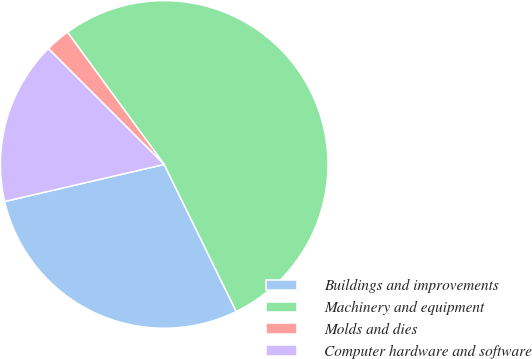Convert chart to OTSL. <chart><loc_0><loc_0><loc_500><loc_500><pie_chart><fcel>Buildings and improvements<fcel>Machinery and equipment<fcel>Molds and dies<fcel>Computer hardware and software<nl><fcel>28.62%<fcel>52.81%<fcel>2.45%<fcel>16.13%<nl></chart> 